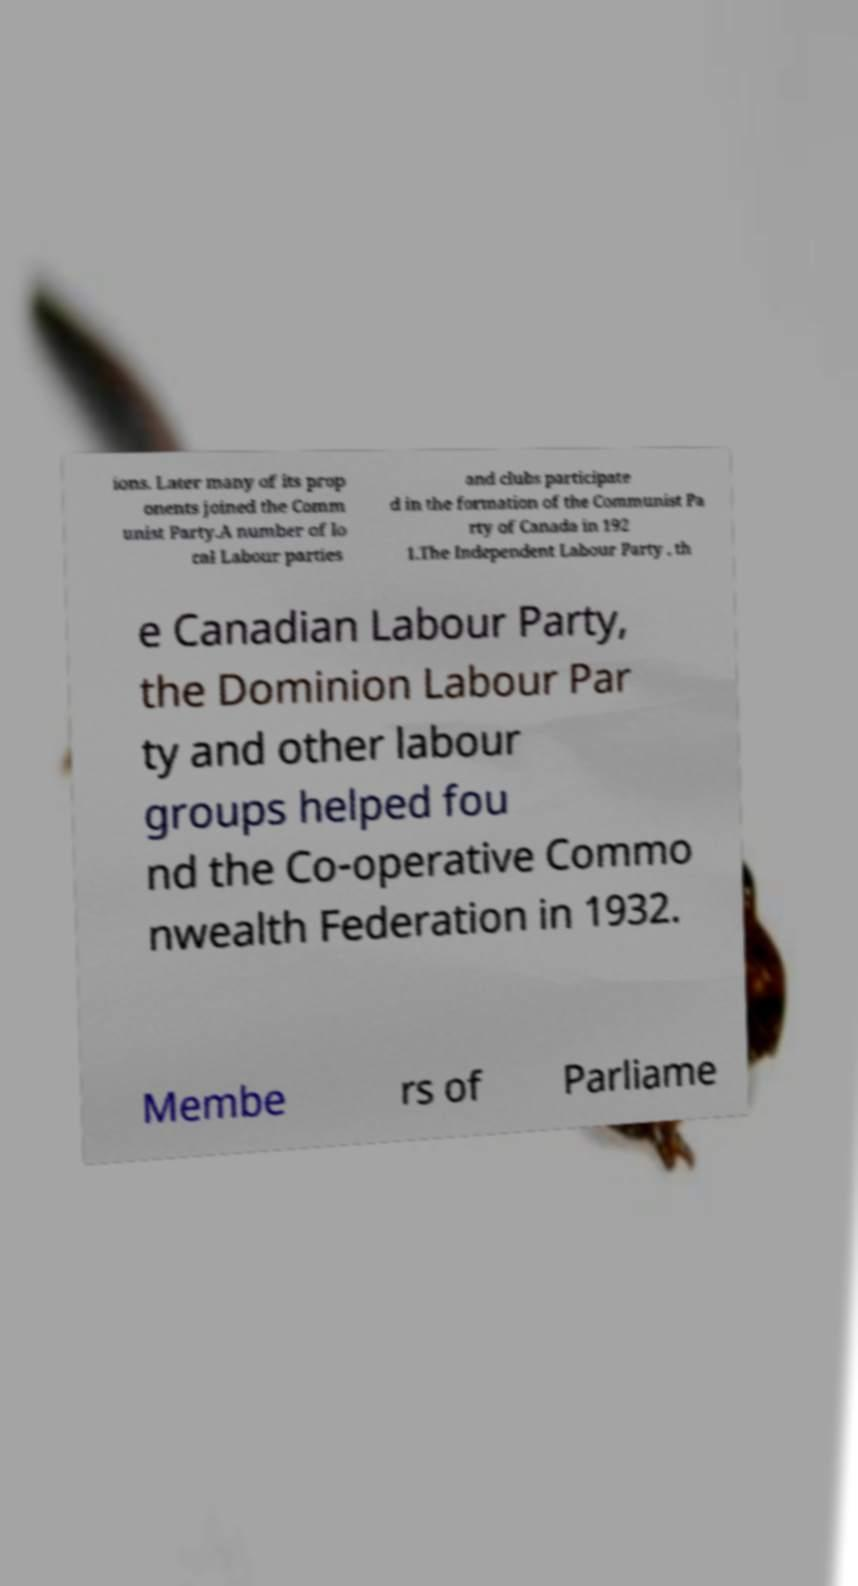What messages or text are displayed in this image? I need them in a readable, typed format. ions. Later many of its prop onents joined the Comm unist Party.A number of lo cal Labour parties and clubs participate d in the formation of the Communist Pa rty of Canada in 192 1.The Independent Labour Party , th e Canadian Labour Party, the Dominion Labour Par ty and other labour groups helped fou nd the Co-operative Commo nwealth Federation in 1932. Membe rs of Parliame 